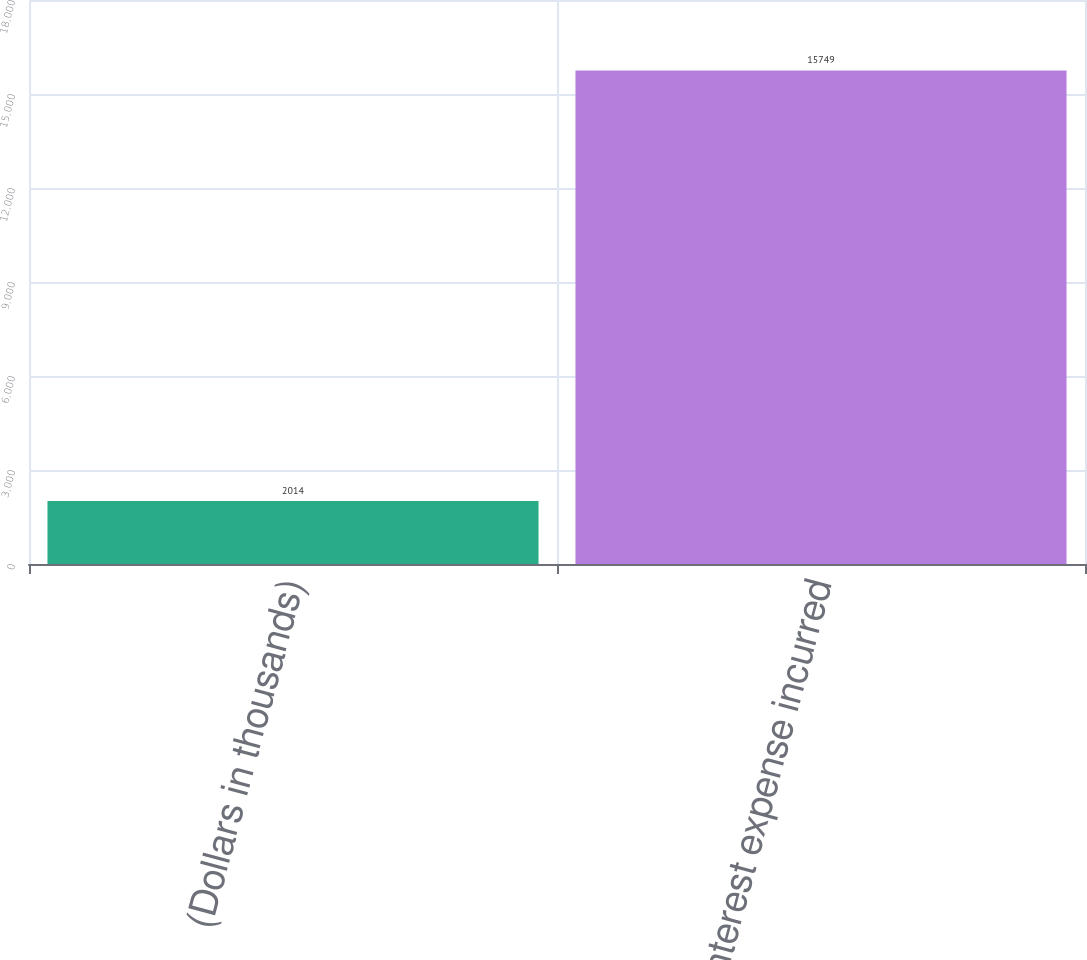<chart> <loc_0><loc_0><loc_500><loc_500><bar_chart><fcel>(Dollars in thousands)<fcel>Interest expense incurred<nl><fcel>2014<fcel>15749<nl></chart> 